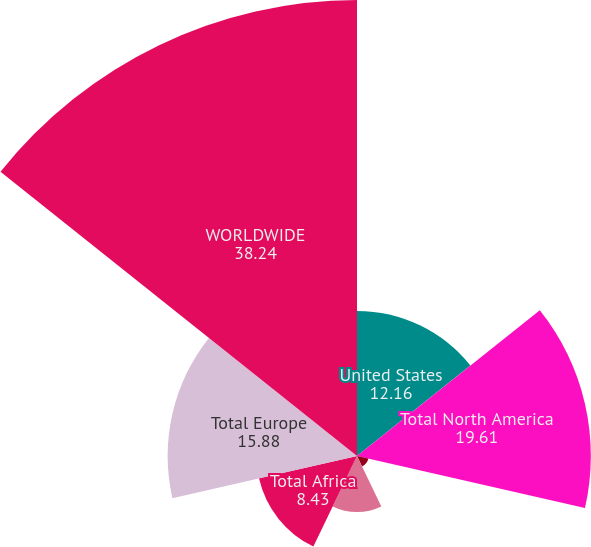Convert chart to OTSL. <chart><loc_0><loc_0><loc_500><loc_500><pie_chart><fcel>United States<fcel>Total North America<fcel>Equatorial Guinea<fcel>Other Africa<fcel>Total Africa<fcel>Total Europe<fcel>WORLDWIDE<nl><fcel>12.16%<fcel>19.61%<fcel>0.98%<fcel>4.7%<fcel>8.43%<fcel>15.88%<fcel>38.24%<nl></chart> 